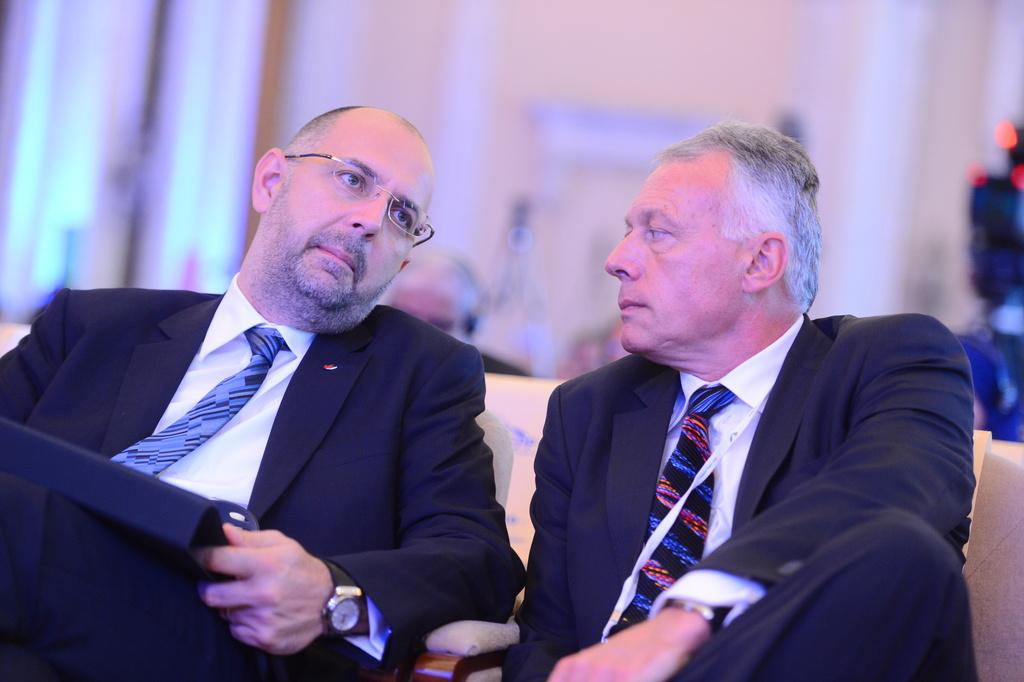Who or what is present in the image? There are people in the image. What are the people wearing? The people are wearing white and black dresses. Where are the people sitting? The people are sitting on a sofa. What verse can be heard being recited by the rabbits in the image? There are no rabbits present in the image, and therefore no verse can be heard being recited by them. 